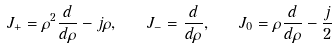Convert formula to latex. <formula><loc_0><loc_0><loc_500><loc_500>J _ { + } = \rho ^ { 2 } \frac { d } { d \rho } - j \rho , \quad J _ { - } = \frac { d } { d \rho } , \quad J _ { 0 } = \rho \frac { d } { d \rho } - \frac { j } { 2 }</formula> 